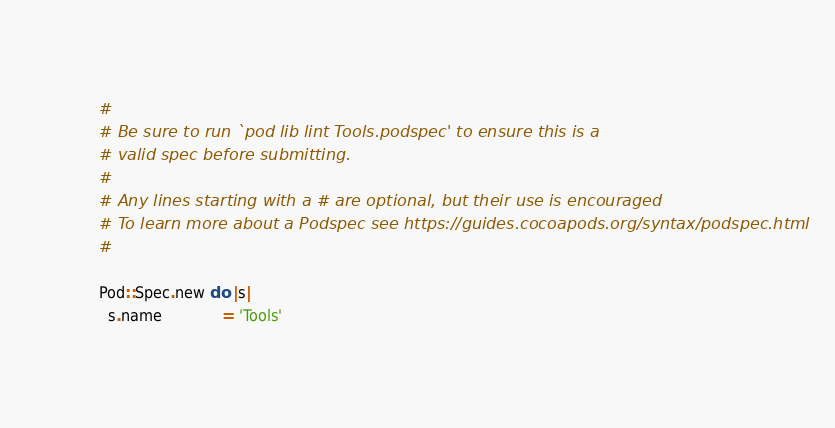<code> <loc_0><loc_0><loc_500><loc_500><_Ruby_>#
# Be sure to run `pod lib lint Tools.podspec' to ensure this is a
# valid spec before submitting.
#
# Any lines starting with a # are optional, but their use is encouraged
# To learn more about a Podspec see https://guides.cocoapods.org/syntax/podspec.html
#

Pod::Spec.new do |s|
  s.name             = 'Tools'</code> 